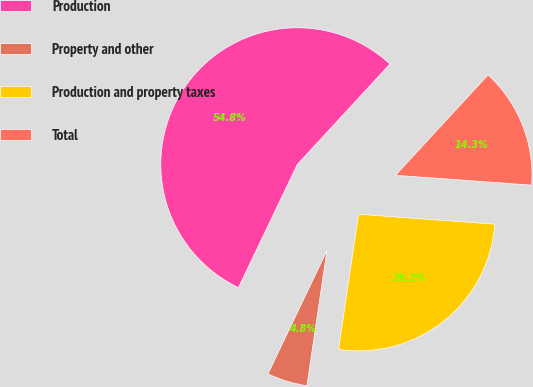Convert chart. <chart><loc_0><loc_0><loc_500><loc_500><pie_chart><fcel>Production<fcel>Property and other<fcel>Production and property taxes<fcel>Total<nl><fcel>54.76%<fcel>4.76%<fcel>26.19%<fcel>14.29%<nl></chart> 